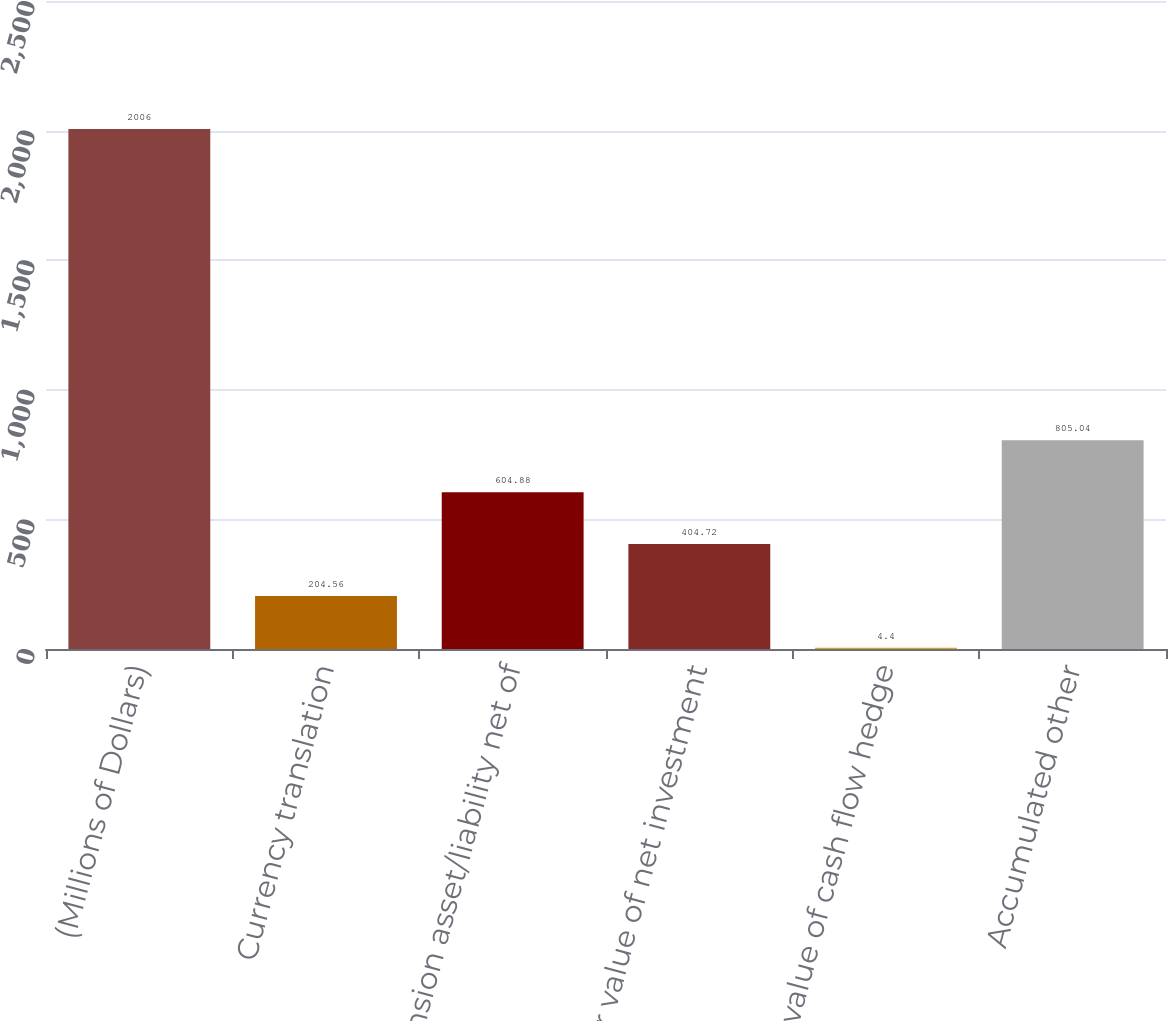<chart> <loc_0><loc_0><loc_500><loc_500><bar_chart><fcel>(Millions of Dollars)<fcel>Currency translation<fcel>pension asset/liability net of<fcel>Fair value of net investment<fcel>Fair value of cash flow hedge<fcel>Accumulated other<nl><fcel>2006<fcel>204.56<fcel>604.88<fcel>404.72<fcel>4.4<fcel>805.04<nl></chart> 